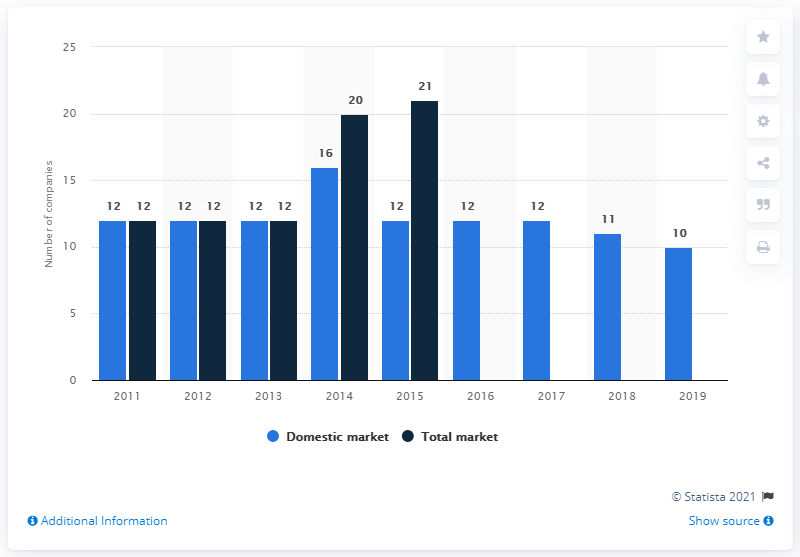List a handful of essential elements in this visual. In 2019, there were 10 companies operating on the Estonian insurance market. In 2014, there were 16 companies active on the Estonian insurance market. From 2011 to 2019, there were 12 companies on the Estonian insurance market. 